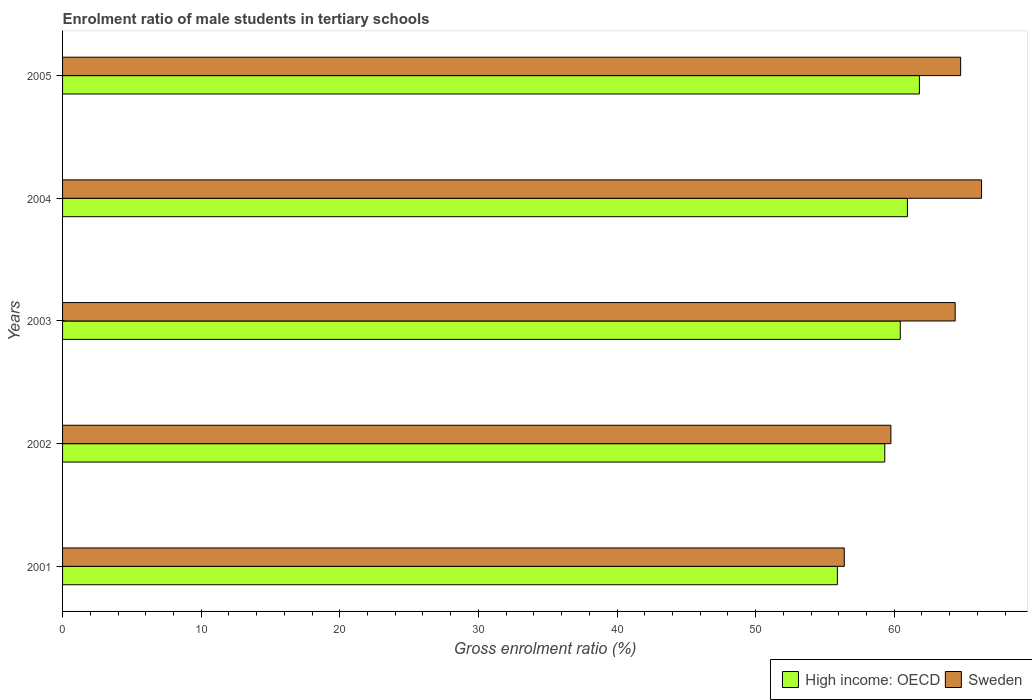How many different coloured bars are there?
Provide a short and direct response. 2. How many groups of bars are there?
Provide a succinct answer. 5. How many bars are there on the 4th tick from the bottom?
Ensure brevity in your answer.  2. What is the label of the 5th group of bars from the top?
Your answer should be very brief. 2001. What is the enrolment ratio of male students in tertiary schools in Sweden in 2005?
Ensure brevity in your answer.  64.79. Across all years, what is the maximum enrolment ratio of male students in tertiary schools in High income: OECD?
Provide a succinct answer. 61.81. Across all years, what is the minimum enrolment ratio of male students in tertiary schools in High income: OECD?
Give a very brief answer. 55.9. What is the total enrolment ratio of male students in tertiary schools in Sweden in the graph?
Your response must be concise. 311.64. What is the difference between the enrolment ratio of male students in tertiary schools in Sweden in 2001 and that in 2002?
Provide a short and direct response. -3.36. What is the difference between the enrolment ratio of male students in tertiary schools in High income: OECD in 2001 and the enrolment ratio of male students in tertiary schools in Sweden in 2003?
Keep it short and to the point. -8.5. What is the average enrolment ratio of male students in tertiary schools in Sweden per year?
Ensure brevity in your answer.  62.33. In the year 2003, what is the difference between the enrolment ratio of male students in tertiary schools in Sweden and enrolment ratio of male students in tertiary schools in High income: OECD?
Give a very brief answer. 3.96. In how many years, is the enrolment ratio of male students in tertiary schools in Sweden greater than 26 %?
Offer a terse response. 5. What is the ratio of the enrolment ratio of male students in tertiary schools in High income: OECD in 2004 to that in 2005?
Your answer should be compact. 0.99. Is the difference between the enrolment ratio of male students in tertiary schools in Sweden in 2003 and 2005 greater than the difference between the enrolment ratio of male students in tertiary schools in High income: OECD in 2003 and 2005?
Provide a short and direct response. Yes. What is the difference between the highest and the second highest enrolment ratio of male students in tertiary schools in High income: OECD?
Ensure brevity in your answer.  0.87. What is the difference between the highest and the lowest enrolment ratio of male students in tertiary schools in Sweden?
Your answer should be compact. 9.9. Is the sum of the enrolment ratio of male students in tertiary schools in Sweden in 2001 and 2003 greater than the maximum enrolment ratio of male students in tertiary schools in High income: OECD across all years?
Keep it short and to the point. Yes. What does the 2nd bar from the top in 2003 represents?
Keep it short and to the point. High income: OECD. What does the 2nd bar from the bottom in 2001 represents?
Provide a short and direct response. Sweden. How many bars are there?
Ensure brevity in your answer.  10. How many years are there in the graph?
Your answer should be very brief. 5. Does the graph contain grids?
Your response must be concise. No. What is the title of the graph?
Your answer should be very brief. Enrolment ratio of male students in tertiary schools. What is the label or title of the X-axis?
Your answer should be very brief. Gross enrolment ratio (%). What is the label or title of the Y-axis?
Your answer should be very brief. Years. What is the Gross enrolment ratio (%) of High income: OECD in 2001?
Make the answer very short. 55.9. What is the Gross enrolment ratio (%) of Sweden in 2001?
Provide a short and direct response. 56.4. What is the Gross enrolment ratio (%) in High income: OECD in 2002?
Provide a succinct answer. 59.32. What is the Gross enrolment ratio (%) in Sweden in 2002?
Your response must be concise. 59.76. What is the Gross enrolment ratio (%) in High income: OECD in 2003?
Give a very brief answer. 60.44. What is the Gross enrolment ratio (%) in Sweden in 2003?
Keep it short and to the point. 64.4. What is the Gross enrolment ratio (%) in High income: OECD in 2004?
Make the answer very short. 60.95. What is the Gross enrolment ratio (%) in Sweden in 2004?
Offer a very short reply. 66.3. What is the Gross enrolment ratio (%) of High income: OECD in 2005?
Provide a short and direct response. 61.81. What is the Gross enrolment ratio (%) in Sweden in 2005?
Your answer should be very brief. 64.79. Across all years, what is the maximum Gross enrolment ratio (%) of High income: OECD?
Provide a succinct answer. 61.81. Across all years, what is the maximum Gross enrolment ratio (%) in Sweden?
Make the answer very short. 66.3. Across all years, what is the minimum Gross enrolment ratio (%) of High income: OECD?
Make the answer very short. 55.9. Across all years, what is the minimum Gross enrolment ratio (%) of Sweden?
Provide a short and direct response. 56.4. What is the total Gross enrolment ratio (%) in High income: OECD in the graph?
Ensure brevity in your answer.  298.41. What is the total Gross enrolment ratio (%) in Sweden in the graph?
Your response must be concise. 311.64. What is the difference between the Gross enrolment ratio (%) in High income: OECD in 2001 and that in 2002?
Ensure brevity in your answer.  -3.42. What is the difference between the Gross enrolment ratio (%) of Sweden in 2001 and that in 2002?
Give a very brief answer. -3.36. What is the difference between the Gross enrolment ratio (%) of High income: OECD in 2001 and that in 2003?
Provide a short and direct response. -4.54. What is the difference between the Gross enrolment ratio (%) of High income: OECD in 2001 and that in 2004?
Ensure brevity in your answer.  -5.05. What is the difference between the Gross enrolment ratio (%) of Sweden in 2001 and that in 2004?
Make the answer very short. -9.9. What is the difference between the Gross enrolment ratio (%) of High income: OECD in 2001 and that in 2005?
Ensure brevity in your answer.  -5.92. What is the difference between the Gross enrolment ratio (%) of Sweden in 2001 and that in 2005?
Your answer should be compact. -8.39. What is the difference between the Gross enrolment ratio (%) of High income: OECD in 2002 and that in 2003?
Ensure brevity in your answer.  -1.12. What is the difference between the Gross enrolment ratio (%) in Sweden in 2002 and that in 2003?
Ensure brevity in your answer.  -4.64. What is the difference between the Gross enrolment ratio (%) in High income: OECD in 2002 and that in 2004?
Make the answer very short. -1.63. What is the difference between the Gross enrolment ratio (%) of Sweden in 2002 and that in 2004?
Your answer should be compact. -6.54. What is the difference between the Gross enrolment ratio (%) in High income: OECD in 2002 and that in 2005?
Your answer should be very brief. -2.5. What is the difference between the Gross enrolment ratio (%) in Sweden in 2002 and that in 2005?
Offer a terse response. -5.03. What is the difference between the Gross enrolment ratio (%) of High income: OECD in 2003 and that in 2004?
Offer a very short reply. -0.51. What is the difference between the Gross enrolment ratio (%) of Sweden in 2003 and that in 2004?
Offer a very short reply. -1.9. What is the difference between the Gross enrolment ratio (%) of High income: OECD in 2003 and that in 2005?
Your response must be concise. -1.38. What is the difference between the Gross enrolment ratio (%) in Sweden in 2003 and that in 2005?
Provide a short and direct response. -0.39. What is the difference between the Gross enrolment ratio (%) of High income: OECD in 2004 and that in 2005?
Provide a short and direct response. -0.87. What is the difference between the Gross enrolment ratio (%) of Sweden in 2004 and that in 2005?
Your response must be concise. 1.51. What is the difference between the Gross enrolment ratio (%) in High income: OECD in 2001 and the Gross enrolment ratio (%) in Sweden in 2002?
Give a very brief answer. -3.86. What is the difference between the Gross enrolment ratio (%) in High income: OECD in 2001 and the Gross enrolment ratio (%) in Sweden in 2003?
Offer a terse response. -8.5. What is the difference between the Gross enrolment ratio (%) of High income: OECD in 2001 and the Gross enrolment ratio (%) of Sweden in 2004?
Keep it short and to the point. -10.4. What is the difference between the Gross enrolment ratio (%) in High income: OECD in 2001 and the Gross enrolment ratio (%) in Sweden in 2005?
Your response must be concise. -8.89. What is the difference between the Gross enrolment ratio (%) of High income: OECD in 2002 and the Gross enrolment ratio (%) of Sweden in 2003?
Make the answer very short. -5.08. What is the difference between the Gross enrolment ratio (%) in High income: OECD in 2002 and the Gross enrolment ratio (%) in Sweden in 2004?
Offer a very short reply. -6.98. What is the difference between the Gross enrolment ratio (%) in High income: OECD in 2002 and the Gross enrolment ratio (%) in Sweden in 2005?
Provide a succinct answer. -5.47. What is the difference between the Gross enrolment ratio (%) in High income: OECD in 2003 and the Gross enrolment ratio (%) in Sweden in 2004?
Ensure brevity in your answer.  -5.86. What is the difference between the Gross enrolment ratio (%) of High income: OECD in 2003 and the Gross enrolment ratio (%) of Sweden in 2005?
Give a very brief answer. -4.35. What is the difference between the Gross enrolment ratio (%) of High income: OECD in 2004 and the Gross enrolment ratio (%) of Sweden in 2005?
Offer a terse response. -3.84. What is the average Gross enrolment ratio (%) in High income: OECD per year?
Your response must be concise. 59.68. What is the average Gross enrolment ratio (%) of Sweden per year?
Provide a succinct answer. 62.33. In the year 2002, what is the difference between the Gross enrolment ratio (%) of High income: OECD and Gross enrolment ratio (%) of Sweden?
Give a very brief answer. -0.44. In the year 2003, what is the difference between the Gross enrolment ratio (%) in High income: OECD and Gross enrolment ratio (%) in Sweden?
Your answer should be compact. -3.96. In the year 2004, what is the difference between the Gross enrolment ratio (%) in High income: OECD and Gross enrolment ratio (%) in Sweden?
Give a very brief answer. -5.35. In the year 2005, what is the difference between the Gross enrolment ratio (%) of High income: OECD and Gross enrolment ratio (%) of Sweden?
Your response must be concise. -2.98. What is the ratio of the Gross enrolment ratio (%) in High income: OECD in 2001 to that in 2002?
Your answer should be very brief. 0.94. What is the ratio of the Gross enrolment ratio (%) in Sweden in 2001 to that in 2002?
Provide a succinct answer. 0.94. What is the ratio of the Gross enrolment ratio (%) of High income: OECD in 2001 to that in 2003?
Ensure brevity in your answer.  0.92. What is the ratio of the Gross enrolment ratio (%) of Sweden in 2001 to that in 2003?
Provide a succinct answer. 0.88. What is the ratio of the Gross enrolment ratio (%) of High income: OECD in 2001 to that in 2004?
Keep it short and to the point. 0.92. What is the ratio of the Gross enrolment ratio (%) of Sweden in 2001 to that in 2004?
Provide a succinct answer. 0.85. What is the ratio of the Gross enrolment ratio (%) of High income: OECD in 2001 to that in 2005?
Your response must be concise. 0.9. What is the ratio of the Gross enrolment ratio (%) in Sweden in 2001 to that in 2005?
Provide a short and direct response. 0.87. What is the ratio of the Gross enrolment ratio (%) in High income: OECD in 2002 to that in 2003?
Offer a very short reply. 0.98. What is the ratio of the Gross enrolment ratio (%) of Sweden in 2002 to that in 2003?
Your answer should be compact. 0.93. What is the ratio of the Gross enrolment ratio (%) in High income: OECD in 2002 to that in 2004?
Ensure brevity in your answer.  0.97. What is the ratio of the Gross enrolment ratio (%) of Sweden in 2002 to that in 2004?
Provide a short and direct response. 0.9. What is the ratio of the Gross enrolment ratio (%) of High income: OECD in 2002 to that in 2005?
Your response must be concise. 0.96. What is the ratio of the Gross enrolment ratio (%) in Sweden in 2002 to that in 2005?
Give a very brief answer. 0.92. What is the ratio of the Gross enrolment ratio (%) in Sweden in 2003 to that in 2004?
Provide a succinct answer. 0.97. What is the ratio of the Gross enrolment ratio (%) in High income: OECD in 2003 to that in 2005?
Make the answer very short. 0.98. What is the ratio of the Gross enrolment ratio (%) in Sweden in 2004 to that in 2005?
Your answer should be very brief. 1.02. What is the difference between the highest and the second highest Gross enrolment ratio (%) of High income: OECD?
Keep it short and to the point. 0.87. What is the difference between the highest and the second highest Gross enrolment ratio (%) of Sweden?
Give a very brief answer. 1.51. What is the difference between the highest and the lowest Gross enrolment ratio (%) of High income: OECD?
Keep it short and to the point. 5.92. What is the difference between the highest and the lowest Gross enrolment ratio (%) of Sweden?
Your answer should be very brief. 9.9. 